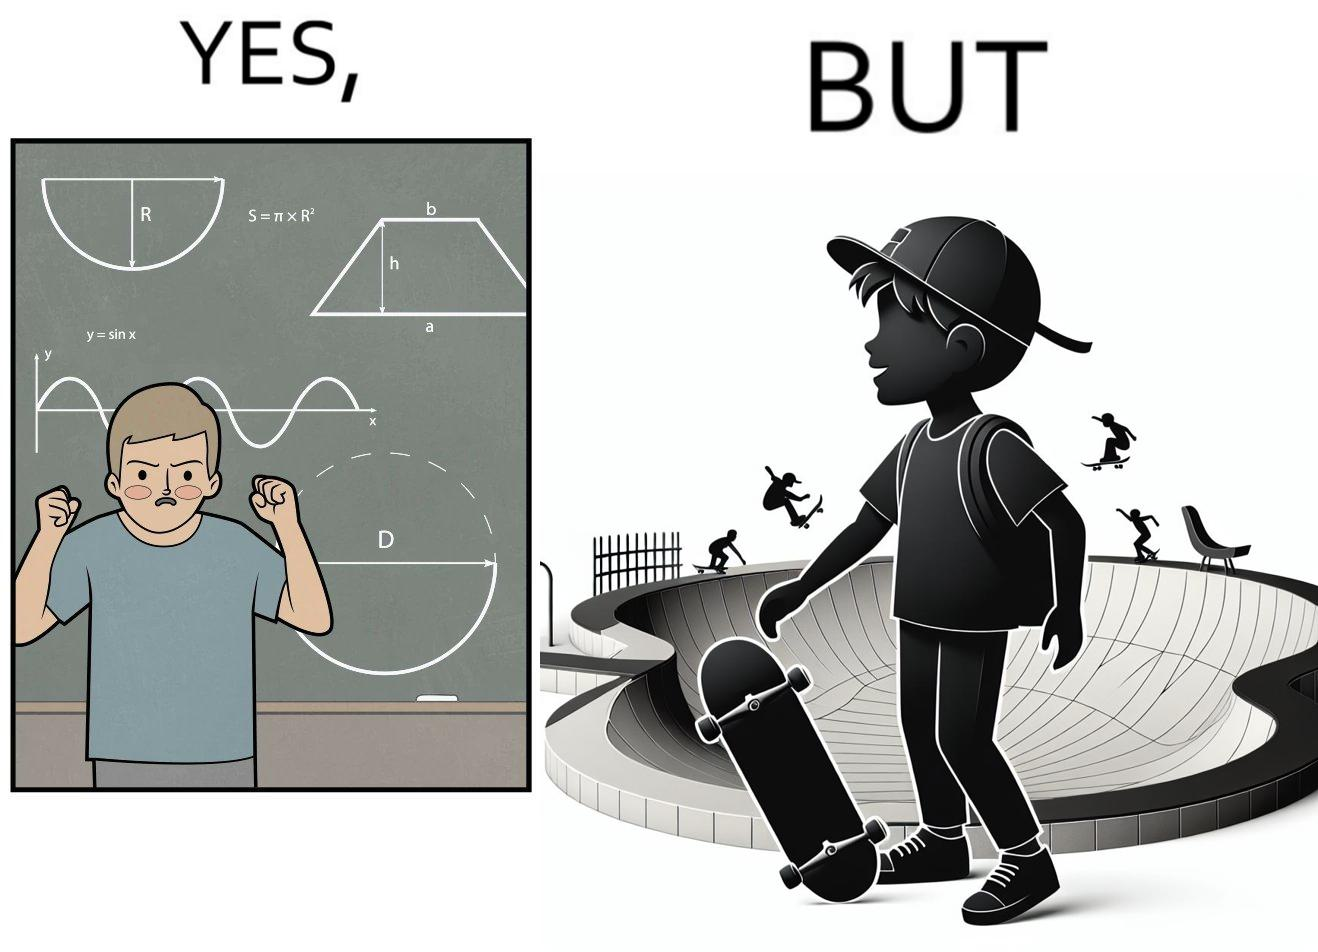Describe what you see in the left and right parts of this image. In the left part of the image: The image shows a boy annoyed with studying maths. Behind him is a board with lots of shapes like  semi-circle and trapezoid drawn along with mathematical formulas like areas of circle. There is a graph of sinusodial curve also drawn on the board. In the right part of the image: The image shows a boy wearing a cap with a skateboard in his hands. He is happy. In his background there is a skateboard park. In the background there is a person skateboarding on a semi cirular bowl. We also see bowls of other shapes like trapezoid and sine wave. 